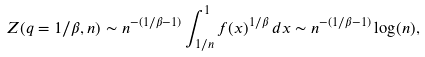Convert formula to latex. <formula><loc_0><loc_0><loc_500><loc_500>Z ( q = 1 / \beta , n ) \sim n ^ { - ( 1 / \beta - 1 ) } \int _ { 1 / n } ^ { 1 } f ( x ) ^ { 1 / \beta } \, d x \sim n ^ { - ( 1 / \beta - 1 ) } \log ( n ) ,</formula> 